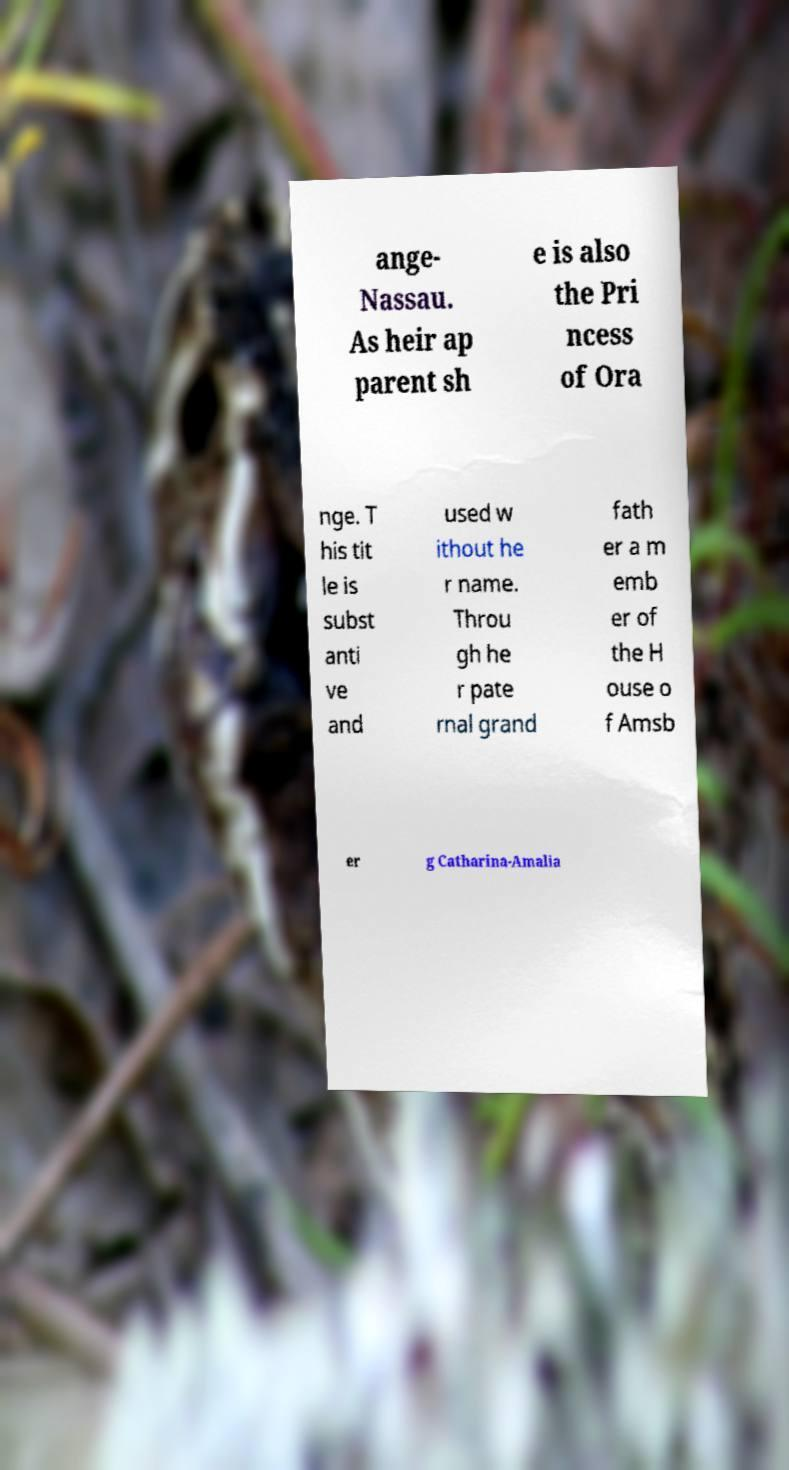Please read and relay the text visible in this image. What does it say? ange- Nassau. As heir ap parent sh e is also the Pri ncess of Ora nge. T his tit le is subst anti ve and used w ithout he r name. Throu gh he r pate rnal grand fath er a m emb er of the H ouse o f Amsb er g Catharina-Amalia 